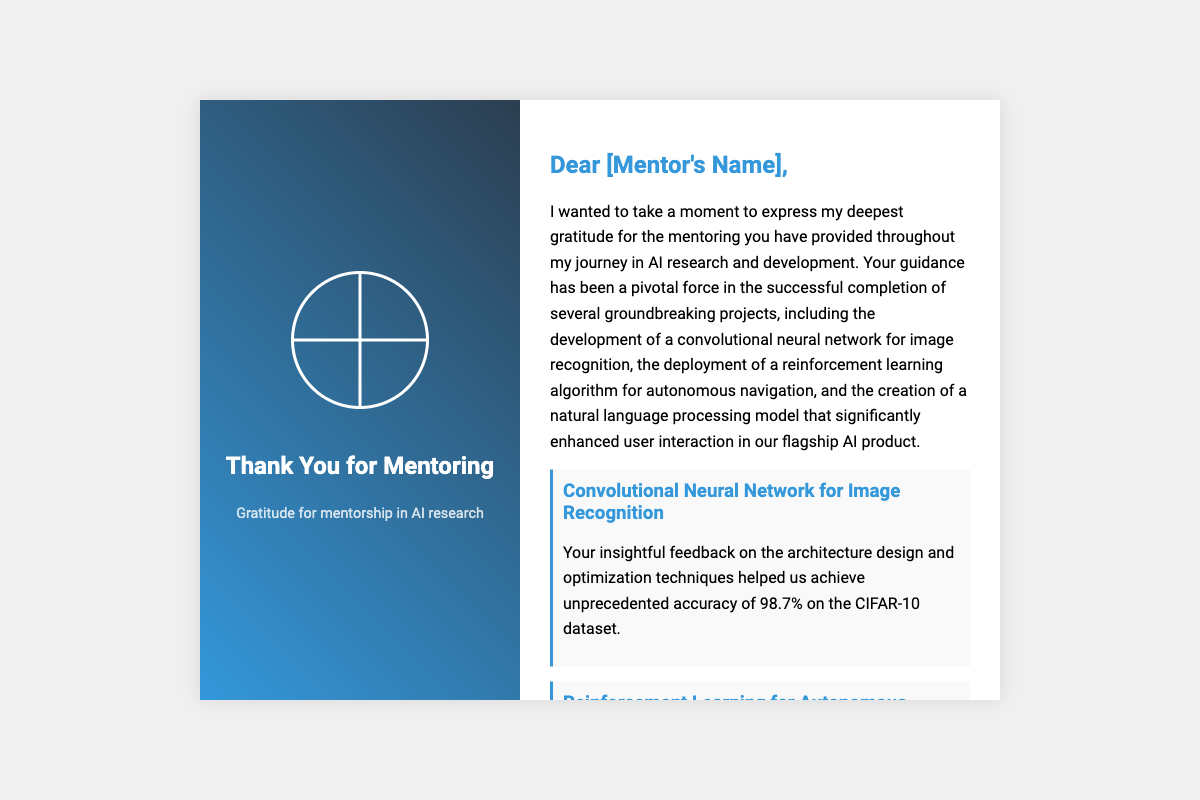What is the mentor's name? The document invites a placeholder for the mentor's name, indicated as [Mentor's Name].
Answer: [Mentor's Name] How many projects are mentioned? Three significant projects are detailed in the thank-you message.
Answer: Three What accuracy was achieved in the convolutional neural network project? The document specifies an accuracy of 98.7% on the CIFAR-10 dataset as a result of the mentorship.
Answer: 98.7% What type of learning was crucial for the autonomous navigation project? The document mentions reinforcement learning as essential for overcoming challenges in the project.
Answer: Reinforcement learning Which AI model's conversational accuracy improved? The document notes improvements in the natural language processing model's conversational accuracy.
Answer: Natural language processing model What effect did the mentor have on the author's career? The author mentions that the mentor inspired a passion for lifelong learning in AI, showing the mentor's impact on their career trajectory.
Answer: Lifelong learning What color is used in the cover's title? The title on the cover is in white, standing out against the background color gradient.
Answer: White What was the main focus of the card? The card's primary focus is expressing gratitude for mentorship in AI research.
Answer: Gratitude for mentorship 